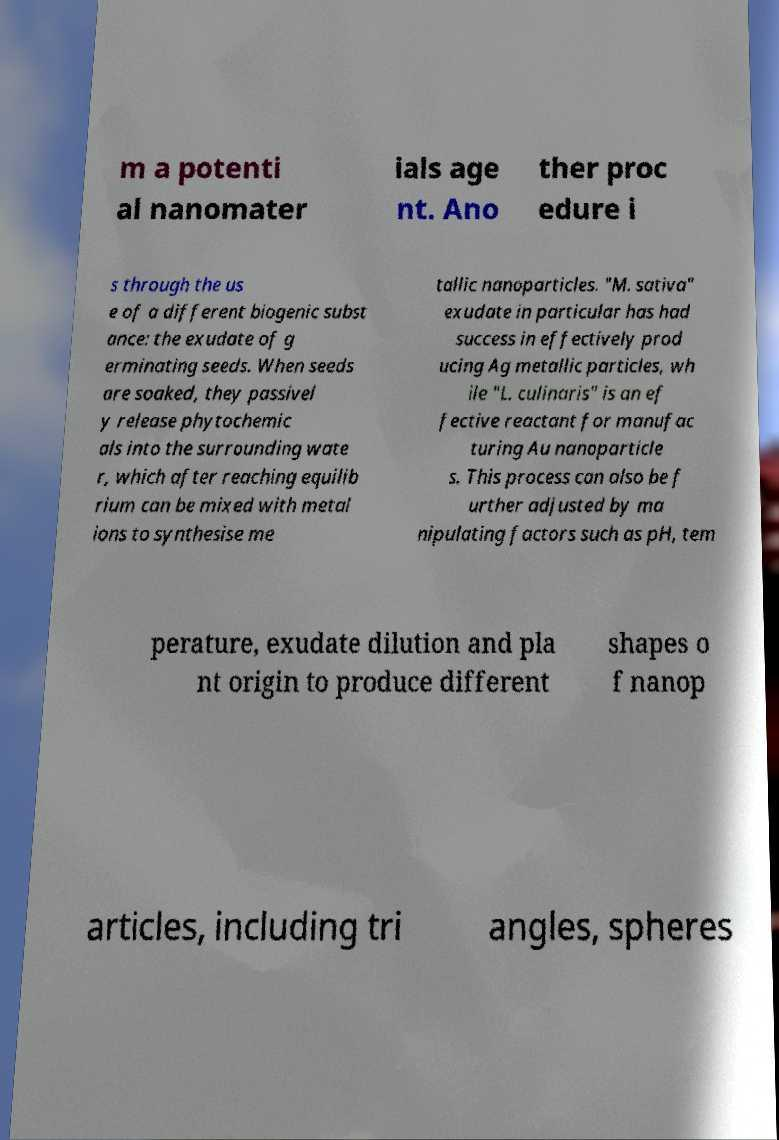What messages or text are displayed in this image? I need them in a readable, typed format. m a potenti al nanomater ials age nt. Ano ther proc edure i s through the us e of a different biogenic subst ance: the exudate of g erminating seeds. When seeds are soaked, they passivel y release phytochemic als into the surrounding wate r, which after reaching equilib rium can be mixed with metal ions to synthesise me tallic nanoparticles. "M. sativa" exudate in particular has had success in effectively prod ucing Ag metallic particles, wh ile "L. culinaris" is an ef fective reactant for manufac turing Au nanoparticle s. This process can also be f urther adjusted by ma nipulating factors such as pH, tem perature, exudate dilution and pla nt origin to produce different shapes o f nanop articles, including tri angles, spheres 